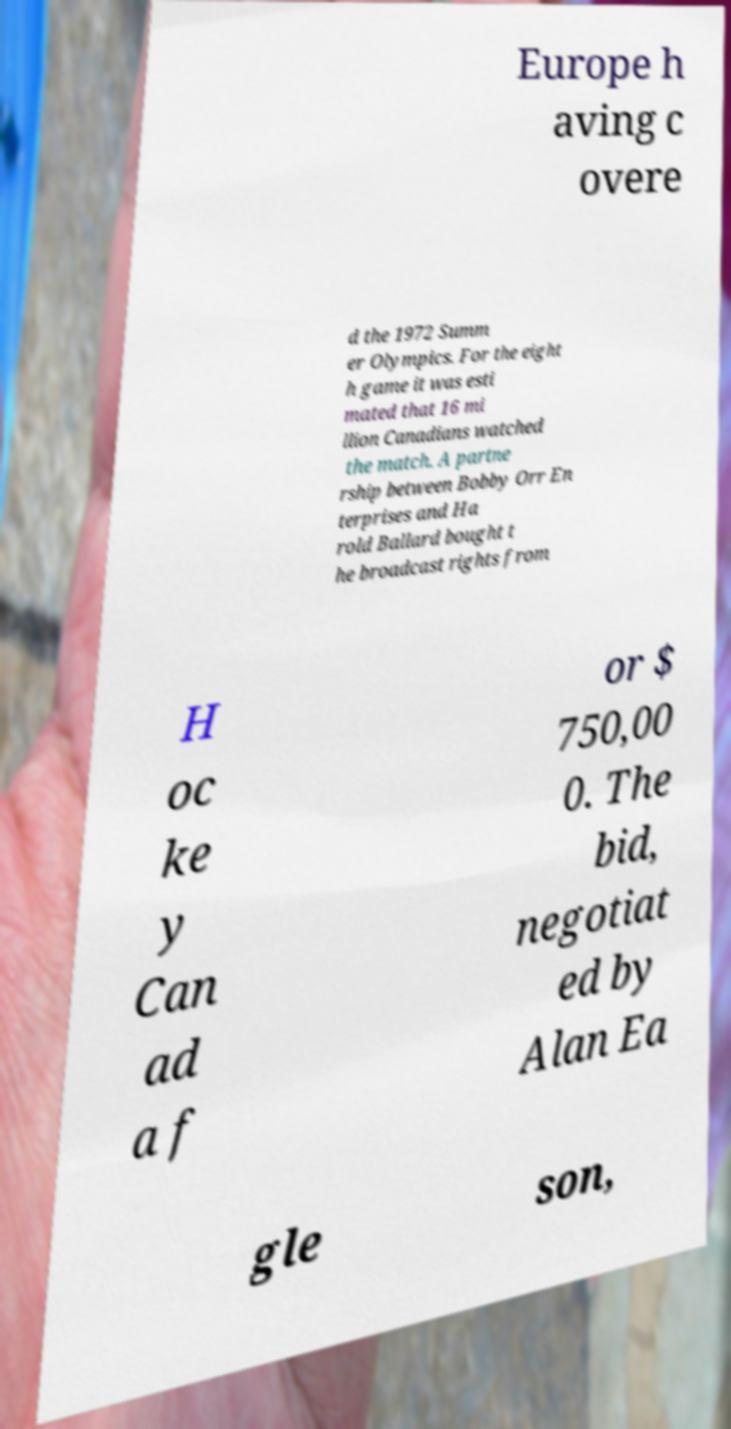For documentation purposes, I need the text within this image transcribed. Could you provide that? Europe h aving c overe d the 1972 Summ er Olympics. For the eight h game it was esti mated that 16 mi llion Canadians watched the match. A partne rship between Bobby Orr En terprises and Ha rold Ballard bought t he broadcast rights from H oc ke y Can ad a f or $ 750,00 0. The bid, negotiat ed by Alan Ea gle son, 